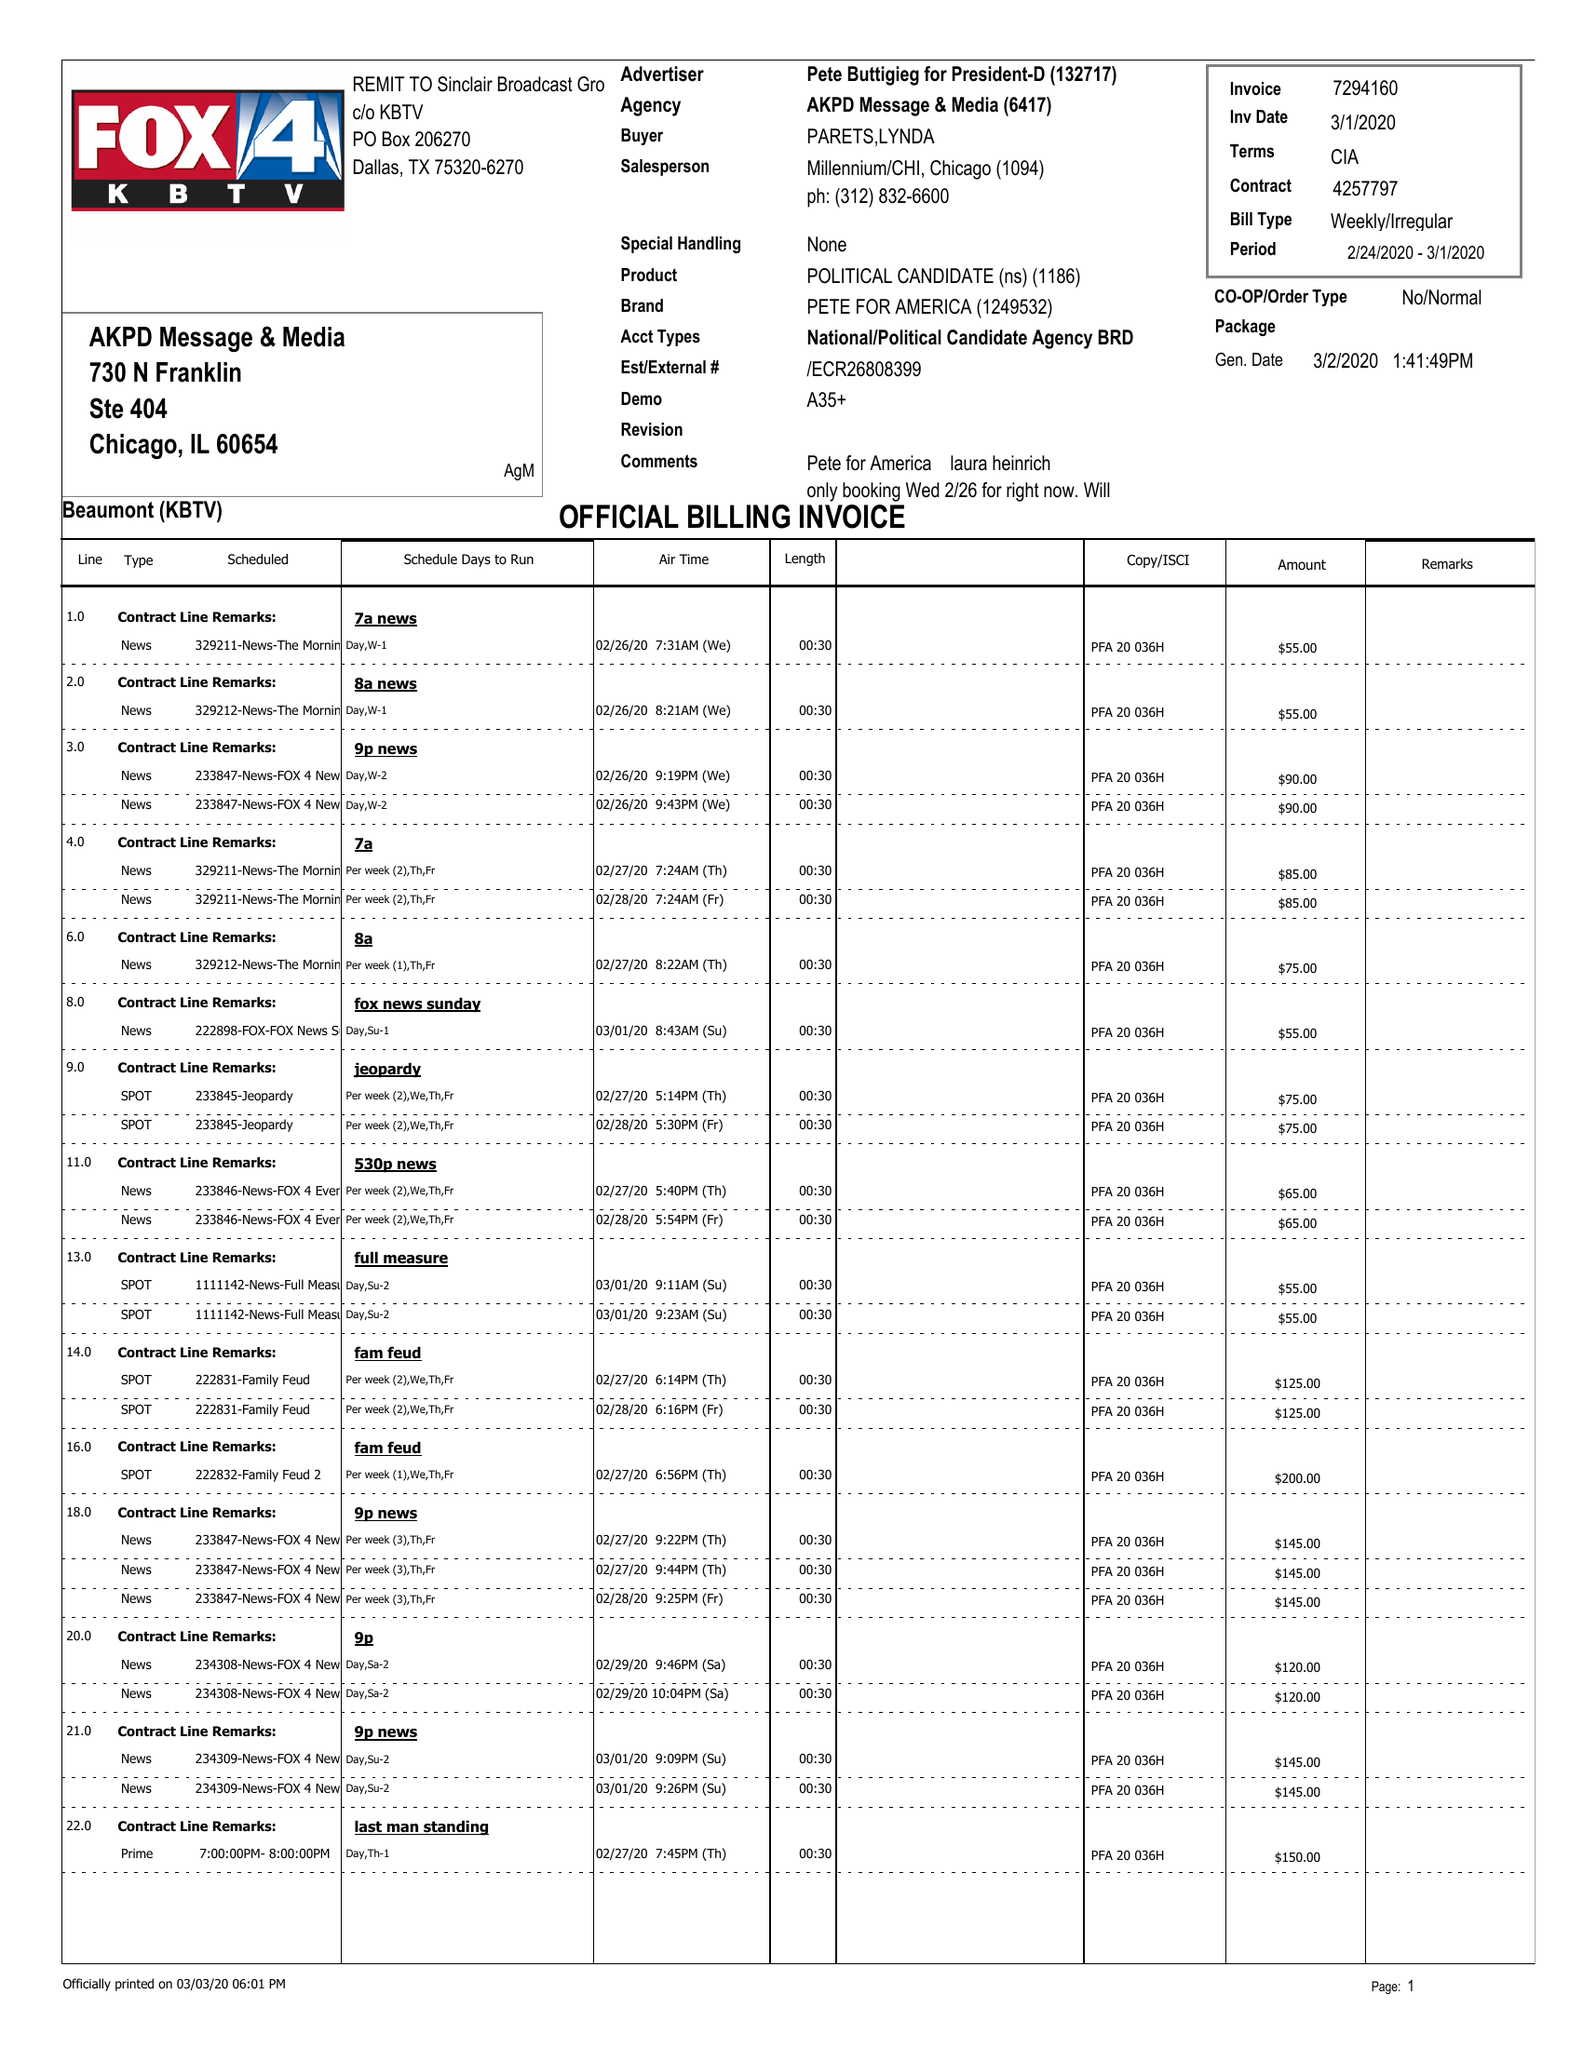What is the value for the flight_to?
Answer the question using a single word or phrase. 03/01/20 